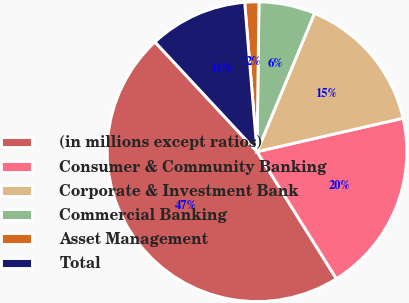Convert chart. <chart><loc_0><loc_0><loc_500><loc_500><pie_chart><fcel>(in millions except ratios)<fcel>Consumer & Community Banking<fcel>Corporate & Investment Bank<fcel>Commercial Banking<fcel>Asset Management<fcel>Total<nl><fcel>46.97%<fcel>19.7%<fcel>15.15%<fcel>6.06%<fcel>1.52%<fcel>10.61%<nl></chart> 